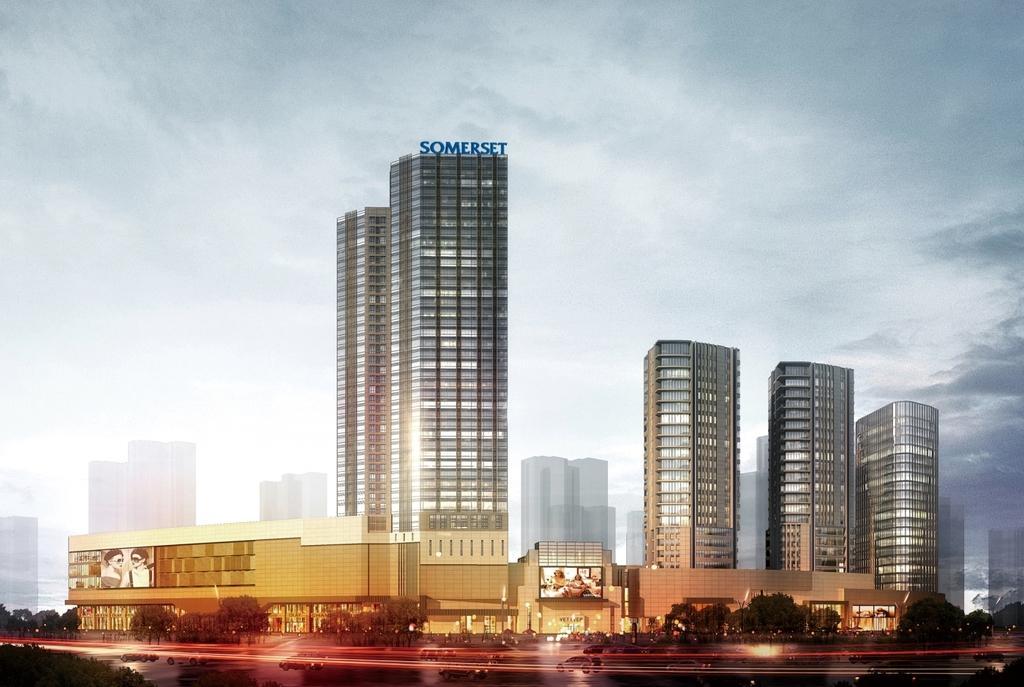Please provide a concise description of this image. In this image we can see some buildings, shops, trees, road on which there are some vehicles moving and top of the image there is clear sky. 